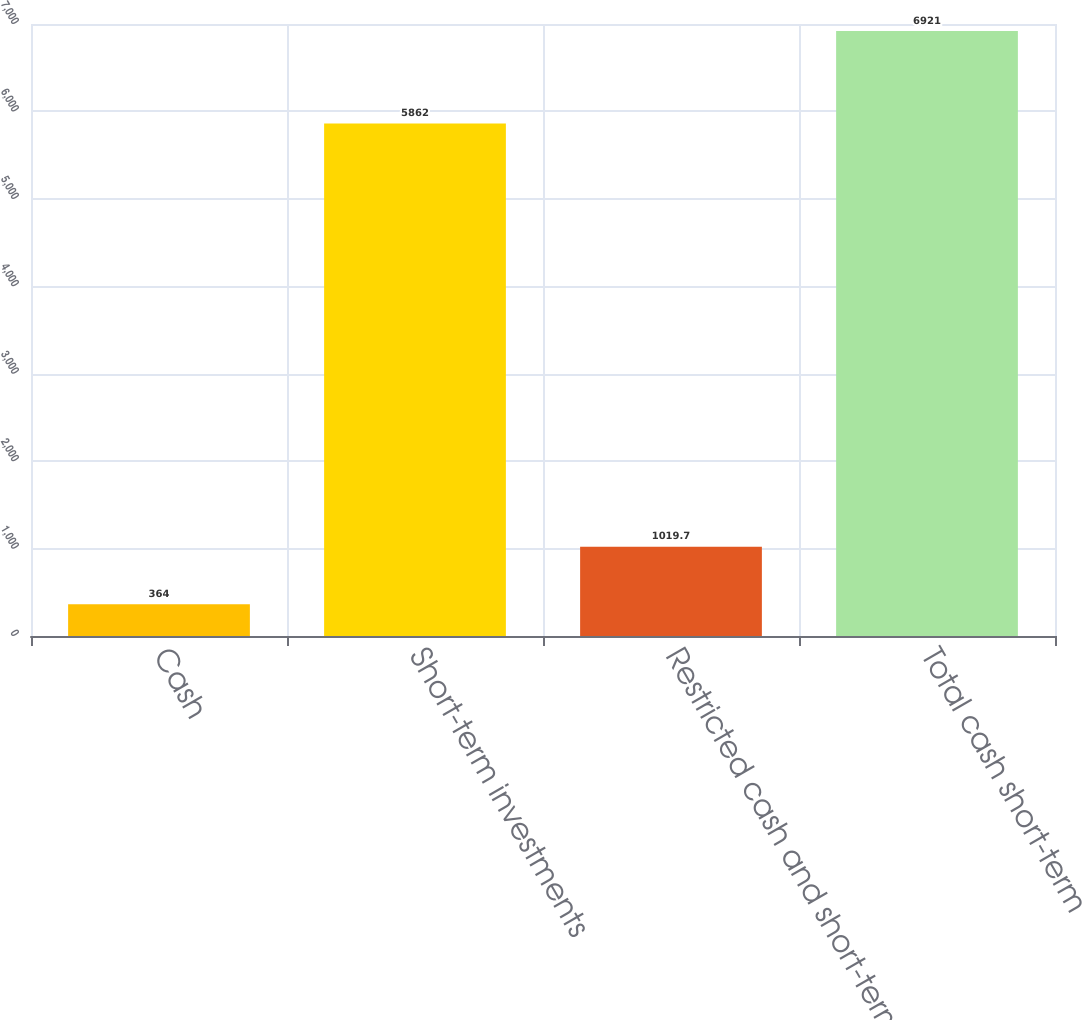Convert chart. <chart><loc_0><loc_0><loc_500><loc_500><bar_chart><fcel>Cash<fcel>Short-term investments<fcel>Restricted cash and short-term<fcel>Total cash short-term<nl><fcel>364<fcel>5862<fcel>1019.7<fcel>6921<nl></chart> 